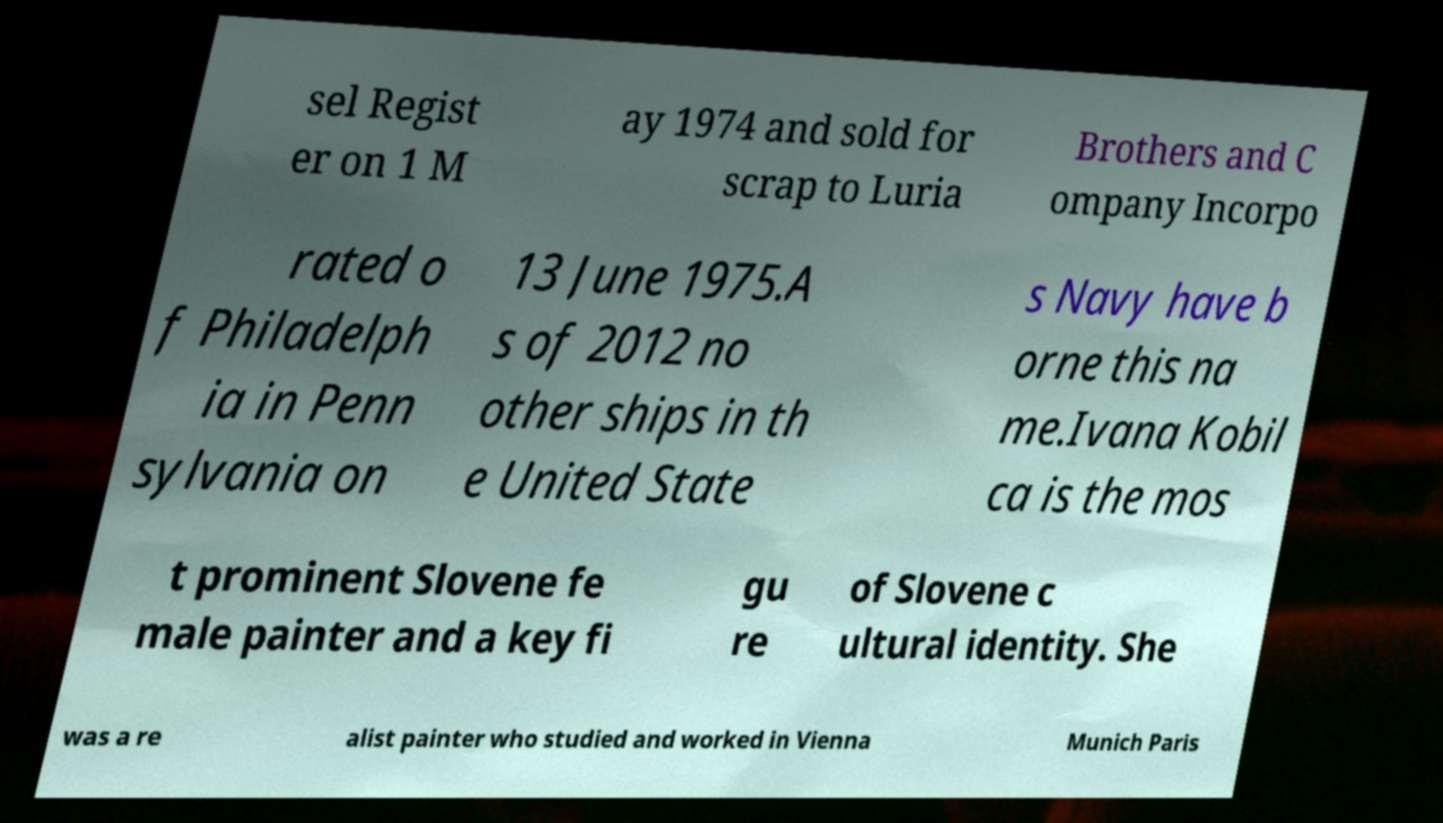What messages or text are displayed in this image? I need them in a readable, typed format. sel Regist er on 1 M ay 1974 and sold for scrap to Luria Brothers and C ompany Incorpo rated o f Philadelph ia in Penn sylvania on 13 June 1975.A s of 2012 no other ships in th e United State s Navy have b orne this na me.Ivana Kobil ca is the mos t prominent Slovene fe male painter and a key fi gu re of Slovene c ultural identity. She was a re alist painter who studied and worked in Vienna Munich Paris 